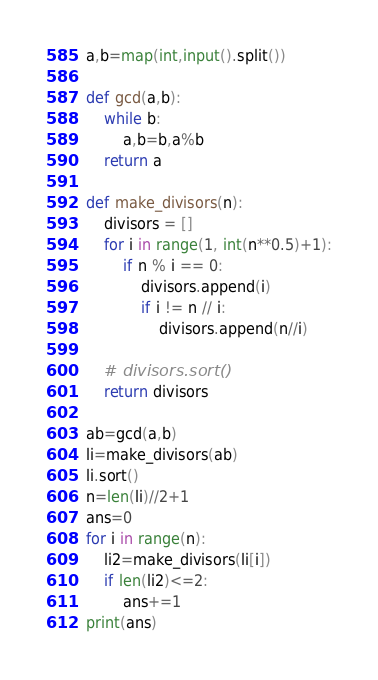Convert code to text. <code><loc_0><loc_0><loc_500><loc_500><_Python_>a,b=map(int,input().split())

def gcd(a,b):
    while b:
        a,b=b,a%b
    return a

def make_divisors(n):
    divisors = []
    for i in range(1, int(n**0.5)+1):
        if n % i == 0:
            divisors.append(i)
            if i != n // i:
                divisors.append(n//i)

    # divisors.sort()
    return divisors

ab=gcd(a,b)
li=make_divisors(ab)
li.sort()
n=len(li)//2+1
ans=0
for i in range(n):
    li2=make_divisors(li[i])
    if len(li2)<=2:
        ans+=1
print(ans)</code> 